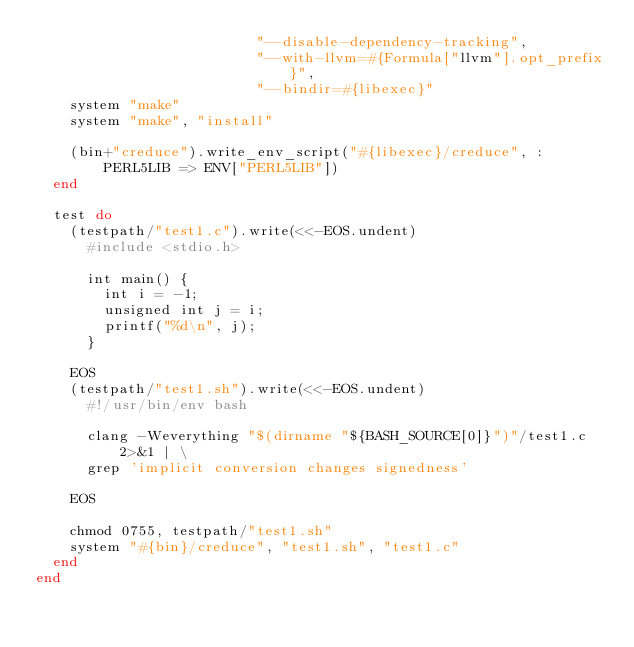<code> <loc_0><loc_0><loc_500><loc_500><_Ruby_>                          "--disable-dependency-tracking",
                          "--with-llvm=#{Formula["llvm"].opt_prefix}",
                          "--bindir=#{libexec}"
    system "make"
    system "make", "install"

    (bin+"creduce").write_env_script("#{libexec}/creduce", :PERL5LIB => ENV["PERL5LIB"])
  end

  test do
    (testpath/"test1.c").write(<<-EOS.undent)
      #include <stdio.h>

      int main() {
        int i = -1;
        unsigned int j = i;
        printf("%d\n", j);
      }

    EOS
    (testpath/"test1.sh").write(<<-EOS.undent)
      #!/usr/bin/env bash

      clang -Weverything "$(dirname "${BASH_SOURCE[0]}")"/test1.c 2>&1 | \
      grep 'implicit conversion changes signedness'

    EOS

    chmod 0755, testpath/"test1.sh"
    system "#{bin}/creduce", "test1.sh", "test1.c"
  end
end
</code> 